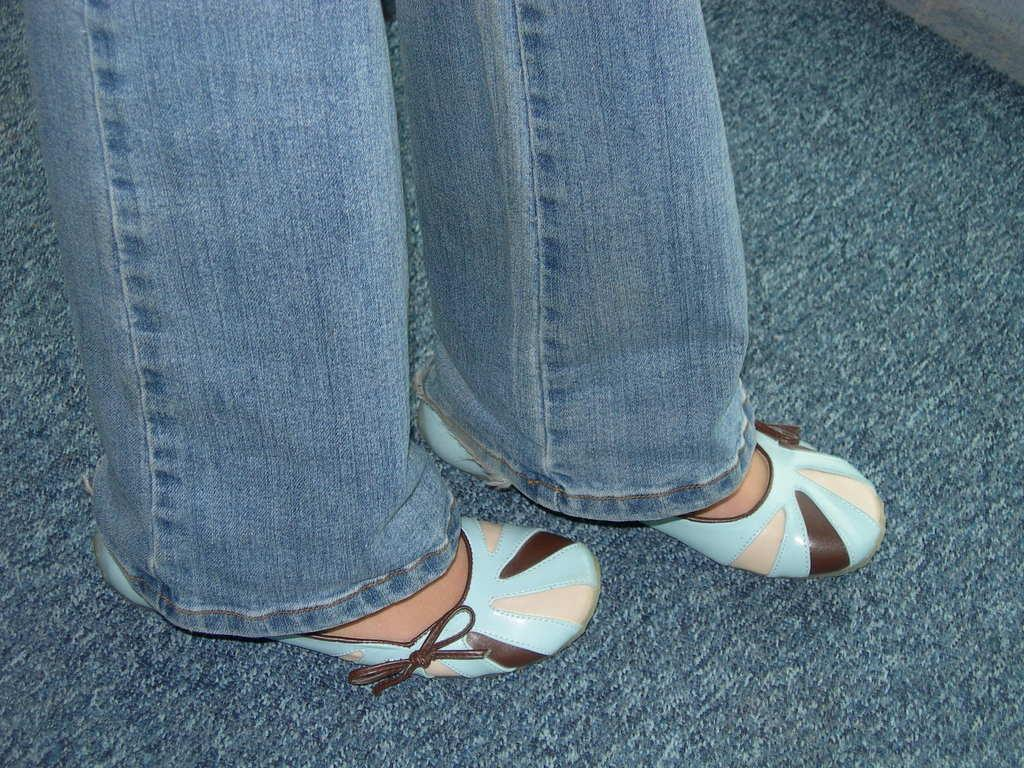What part of a person can be seen in the image? There are legs of a person visible in the image. Where are the legs located in relation to the floor? The legs are on the floor. What type of rose can be seen in the image? There is no rose present in the image; it only shows the legs of a person on the floor. 